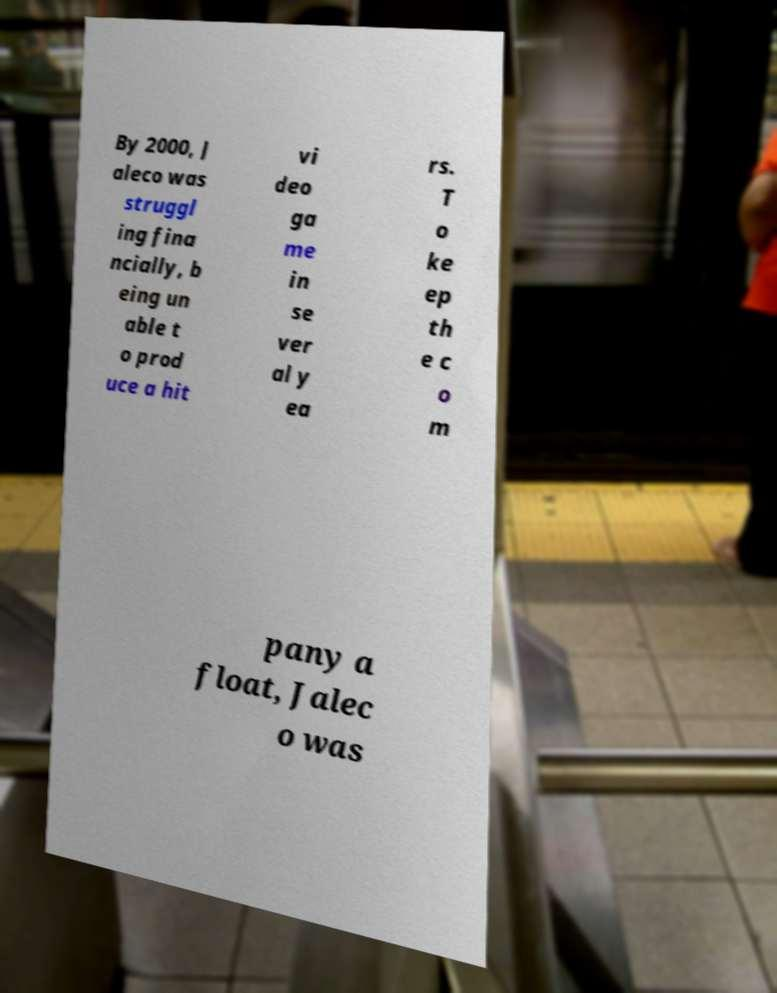Could you extract and type out the text from this image? By 2000, J aleco was struggl ing fina ncially, b eing un able t o prod uce a hit vi deo ga me in se ver al y ea rs. T o ke ep th e c o m pany a float, Jalec o was 